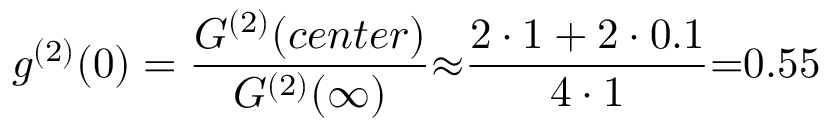Convert formula to latex. <formula><loc_0><loc_0><loc_500><loc_500>g ^ { ( 2 ) } ( 0 ) = \frac { G ^ { ( 2 ) } ( c e n t e r ) } { G ^ { ( 2 ) } ( \infty ) } { \approx } \frac { 2 \cdot 1 + 2 \cdot 0 . 1 } { 4 \cdot 1 } { = } 0 . 5 5</formula> 